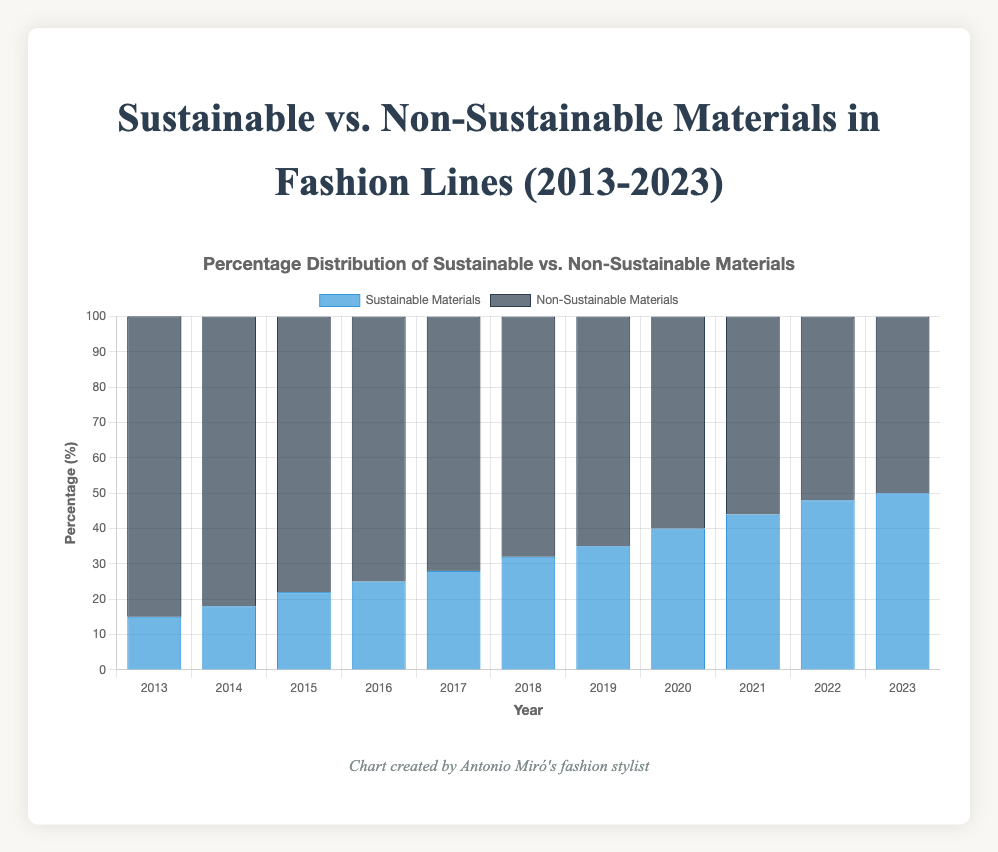What is the highest percentage of sustainable materials in any given year? By reading the bar chart, the highest percentage for sustainable materials is in the year 2023. The value reaches 50%.
Answer: 50% What is the trend in the percentage of non-sustainable materials over the years? The trend observed from the chart shows that the percentage of non-sustainable materials gradually decreases each year, starting from 85% in 2013 to 50% in 2023.
Answer: Decreasing How much did the percentage of sustainable materials increase from 2013 to 2023? To determine the increase, take the sustainable materials percentage in 2023 and subtract the percentage in 2013. So, it's 50% in 2023 minus 15% in 2013, which results in an increase of 35%.
Answer: 35% In which year did the percentage of sustainable materials surpass 30% for the first time? By observing the chart, the year 2018 shows a sustainable materials percentage of 32%, which surpasses the 30% mark.
Answer: 2018 Compare the percentages of sustainable and non-sustainable materials in 2016. The chart shows that in 2016, the percentage of sustainable materials is 25% while non-sustainable materials is 75%.
Answer: Sustainable: 25%, Non-Sustainable: 75% What is the average percentage of sustainable materials over the last decade? Calculate the average by summing the percentages of sustainable materials from 2013 to 2023 and then dividing by the number of years. (15 + 18 + 22 + 25 + 28 + 32 + 35 + 40 + 44 + 48 + 50) / 11 = 32.91% (rounded to two decimals)
Answer: 32.91% Between which years did the percentage of sustainable materials have the largest increase? To find the largest increase, observe the consecutive year changes and find the maximum. Comparing the data points, the biggest increase is between 2019 (35%) and 2020 (40%), which is an increase of 5%.
Answer: 2019 to 2020 By how much did the percentage of non-sustainable materials decrease from 2020 to 2023? Find the percentage of non-sustainable materials for the years 2020 and 2023, then subtract the later from the former. It's 60% in 2020 and 50% in 2023, so the decrease is 60% - 50% = 10%.
Answer: 10% What are the percentages of sustainable and non-sustainable materials in 2023? Referring to the chart, in the year 2023, the percentages are 50% for sustainable materials and 50% for non-sustainable materials.
Answer: Sustainable: 50%, Non-Sustainable: 50% 